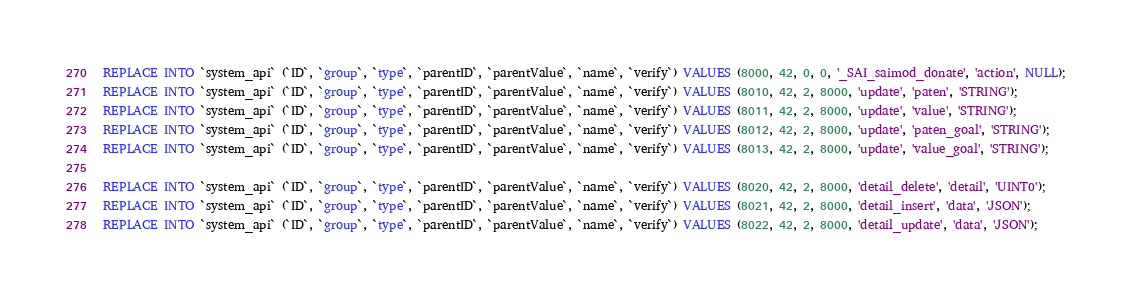Convert code to text. <code><loc_0><loc_0><loc_500><loc_500><_SQL_>REPLACE INTO `system_api` (`ID`, `group`, `type`, `parentID`, `parentValue`, `name`, `verify`) VALUES (8000, 42, 0, 0, '_SAI_saimod_donate', 'action', NULL);
REPLACE INTO `system_api` (`ID`, `group`, `type`, `parentID`, `parentValue`, `name`, `verify`) VALUES (8010, 42, 2, 8000, 'update', 'paten', 'STRING');
REPLACE INTO `system_api` (`ID`, `group`, `type`, `parentID`, `parentValue`, `name`, `verify`) VALUES (8011, 42, 2, 8000, 'update', 'value', 'STRING');
REPLACE INTO `system_api` (`ID`, `group`, `type`, `parentID`, `parentValue`, `name`, `verify`) VALUES (8012, 42, 2, 8000, 'update', 'paten_goal', 'STRING');
REPLACE INTO `system_api` (`ID`, `group`, `type`, `parentID`, `parentValue`, `name`, `verify`) VALUES (8013, 42, 2, 8000, 'update', 'value_goal', 'STRING');

REPLACE INTO `system_api` (`ID`, `group`, `type`, `parentID`, `parentValue`, `name`, `verify`) VALUES (8020, 42, 2, 8000, 'detail_delete', 'detail', 'UINT0');
REPLACE INTO `system_api` (`ID`, `group`, `type`, `parentID`, `parentValue`, `name`, `verify`) VALUES (8021, 42, 2, 8000, 'detail_insert', 'data', 'JSON');
REPLACE INTO `system_api` (`ID`, `group`, `type`, `parentID`, `parentValue`, `name`, `verify`) VALUES (8022, 42, 2, 8000, 'detail_update', 'data', 'JSON');</code> 